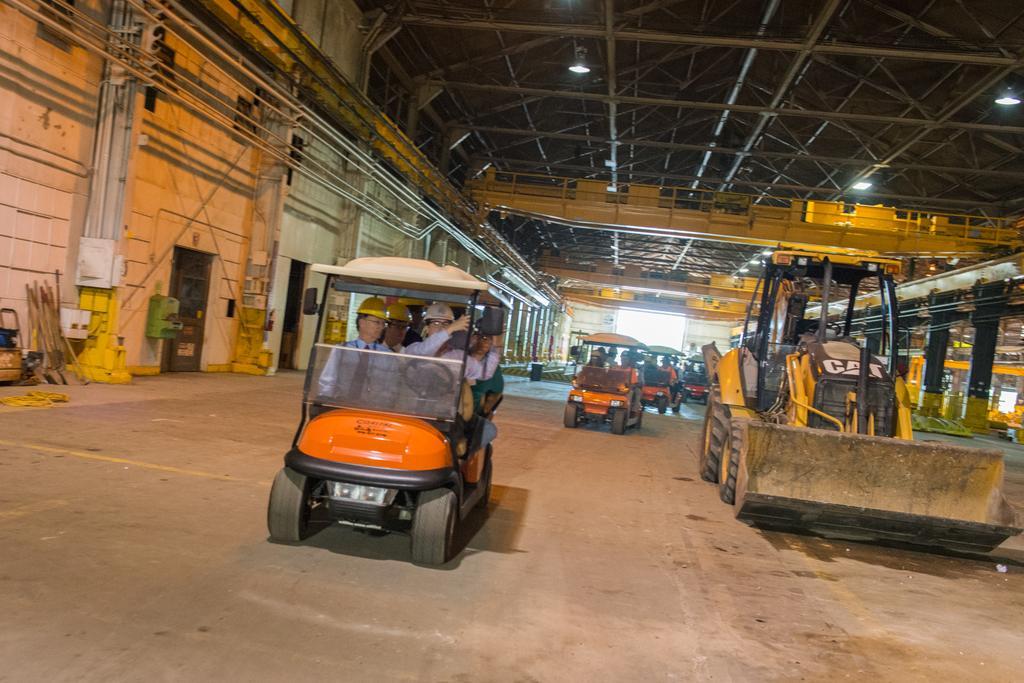Could you give a brief overview of what you see in this image? In this picture I can see a vehicles which are running in the factory. In the orange vehicle I can see many people who are sitting. On the left I can see the pipes, poles, sticks and doors. At the top I can see the lights which are hanging on the roof. 